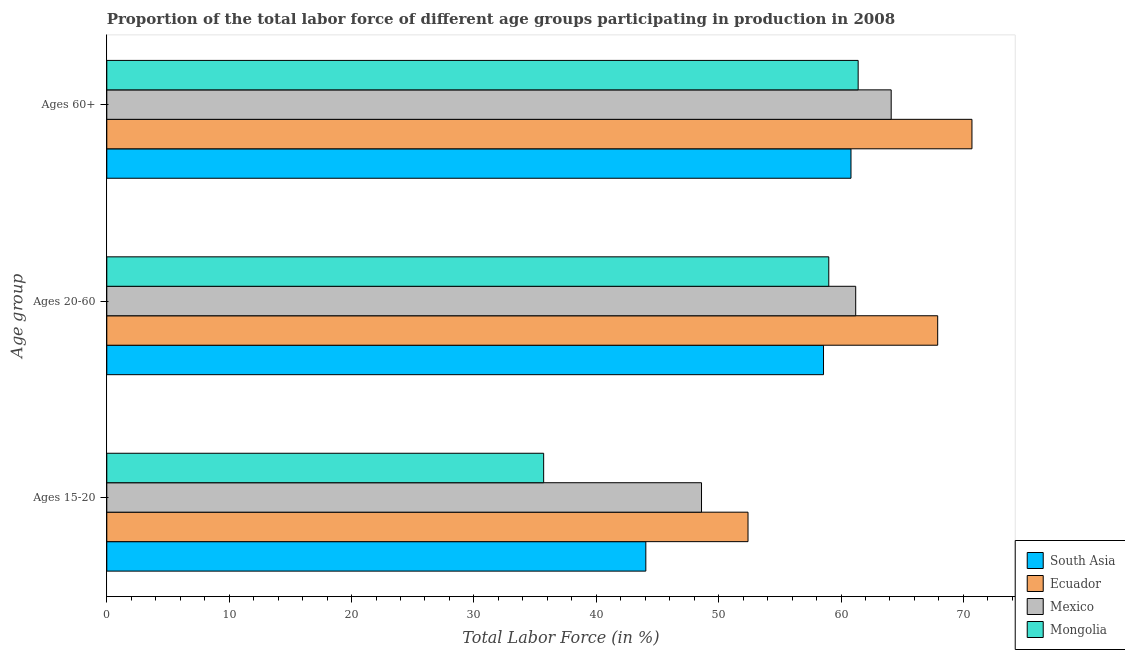How many different coloured bars are there?
Offer a terse response. 4. How many groups of bars are there?
Ensure brevity in your answer.  3. Are the number of bars per tick equal to the number of legend labels?
Ensure brevity in your answer.  Yes. Are the number of bars on each tick of the Y-axis equal?
Make the answer very short. Yes. How many bars are there on the 2nd tick from the top?
Make the answer very short. 4. What is the label of the 2nd group of bars from the top?
Provide a succinct answer. Ages 20-60. What is the percentage of labor force within the age group 20-60 in South Asia?
Your answer should be very brief. 58.57. Across all countries, what is the maximum percentage of labor force within the age group 20-60?
Your response must be concise. 67.9. Across all countries, what is the minimum percentage of labor force above age 60?
Your answer should be compact. 60.82. In which country was the percentage of labor force within the age group 15-20 maximum?
Keep it short and to the point. Ecuador. In which country was the percentage of labor force above age 60 minimum?
Ensure brevity in your answer.  South Asia. What is the total percentage of labor force within the age group 20-60 in the graph?
Your answer should be compact. 246.67. What is the difference between the percentage of labor force within the age group 15-20 in Mongolia and that in South Asia?
Make the answer very short. -8.35. What is the difference between the percentage of labor force above age 60 in Ecuador and the percentage of labor force within the age group 15-20 in Mongolia?
Give a very brief answer. 35. What is the average percentage of labor force within the age group 15-20 per country?
Provide a succinct answer. 45.19. What is the difference between the percentage of labor force above age 60 and percentage of labor force within the age group 20-60 in South Asia?
Offer a terse response. 2.25. In how many countries, is the percentage of labor force within the age group 20-60 greater than 60 %?
Your response must be concise. 2. What is the ratio of the percentage of labor force above age 60 in Mexico to that in Mongolia?
Offer a very short reply. 1.04. Is the difference between the percentage of labor force within the age group 20-60 in Mongolia and South Asia greater than the difference between the percentage of labor force above age 60 in Mongolia and South Asia?
Provide a succinct answer. No. What is the difference between the highest and the second highest percentage of labor force within the age group 15-20?
Your answer should be very brief. 3.8. What is the difference between the highest and the lowest percentage of labor force within the age group 15-20?
Your response must be concise. 16.7. In how many countries, is the percentage of labor force within the age group 20-60 greater than the average percentage of labor force within the age group 20-60 taken over all countries?
Keep it short and to the point. 1. Is the sum of the percentage of labor force within the age group 20-60 in Mongolia and Mexico greater than the maximum percentage of labor force above age 60 across all countries?
Provide a succinct answer. Yes. What does the 2nd bar from the top in Ages 15-20 represents?
Your answer should be very brief. Mexico. What does the 3rd bar from the bottom in Ages 60+ represents?
Provide a succinct answer. Mexico. Is it the case that in every country, the sum of the percentage of labor force within the age group 15-20 and percentage of labor force within the age group 20-60 is greater than the percentage of labor force above age 60?
Provide a short and direct response. Yes. How many bars are there?
Give a very brief answer. 12. Are all the bars in the graph horizontal?
Give a very brief answer. Yes. What is the difference between two consecutive major ticks on the X-axis?
Your answer should be compact. 10. Are the values on the major ticks of X-axis written in scientific E-notation?
Give a very brief answer. No. Where does the legend appear in the graph?
Make the answer very short. Bottom right. What is the title of the graph?
Provide a succinct answer. Proportion of the total labor force of different age groups participating in production in 2008. Does "India" appear as one of the legend labels in the graph?
Make the answer very short. No. What is the label or title of the X-axis?
Make the answer very short. Total Labor Force (in %). What is the label or title of the Y-axis?
Provide a short and direct response. Age group. What is the Total Labor Force (in %) of South Asia in Ages 15-20?
Ensure brevity in your answer.  44.05. What is the Total Labor Force (in %) of Ecuador in Ages 15-20?
Your answer should be compact. 52.4. What is the Total Labor Force (in %) of Mexico in Ages 15-20?
Make the answer very short. 48.6. What is the Total Labor Force (in %) of Mongolia in Ages 15-20?
Provide a short and direct response. 35.7. What is the Total Labor Force (in %) in South Asia in Ages 20-60?
Offer a terse response. 58.57. What is the Total Labor Force (in %) of Ecuador in Ages 20-60?
Ensure brevity in your answer.  67.9. What is the Total Labor Force (in %) in Mexico in Ages 20-60?
Offer a terse response. 61.2. What is the Total Labor Force (in %) of Mongolia in Ages 20-60?
Provide a short and direct response. 59. What is the Total Labor Force (in %) in South Asia in Ages 60+?
Offer a terse response. 60.82. What is the Total Labor Force (in %) of Ecuador in Ages 60+?
Offer a very short reply. 70.7. What is the Total Labor Force (in %) of Mexico in Ages 60+?
Your answer should be compact. 64.1. What is the Total Labor Force (in %) of Mongolia in Ages 60+?
Give a very brief answer. 61.4. Across all Age group, what is the maximum Total Labor Force (in %) in South Asia?
Offer a very short reply. 60.82. Across all Age group, what is the maximum Total Labor Force (in %) in Ecuador?
Give a very brief answer. 70.7. Across all Age group, what is the maximum Total Labor Force (in %) in Mexico?
Provide a succinct answer. 64.1. Across all Age group, what is the maximum Total Labor Force (in %) in Mongolia?
Provide a short and direct response. 61.4. Across all Age group, what is the minimum Total Labor Force (in %) in South Asia?
Offer a very short reply. 44.05. Across all Age group, what is the minimum Total Labor Force (in %) in Ecuador?
Provide a short and direct response. 52.4. Across all Age group, what is the minimum Total Labor Force (in %) in Mexico?
Provide a succinct answer. 48.6. Across all Age group, what is the minimum Total Labor Force (in %) in Mongolia?
Your answer should be very brief. 35.7. What is the total Total Labor Force (in %) in South Asia in the graph?
Offer a very short reply. 163.43. What is the total Total Labor Force (in %) of Ecuador in the graph?
Provide a short and direct response. 191. What is the total Total Labor Force (in %) of Mexico in the graph?
Offer a terse response. 173.9. What is the total Total Labor Force (in %) in Mongolia in the graph?
Your answer should be very brief. 156.1. What is the difference between the Total Labor Force (in %) of South Asia in Ages 15-20 and that in Ages 20-60?
Make the answer very short. -14.52. What is the difference between the Total Labor Force (in %) in Ecuador in Ages 15-20 and that in Ages 20-60?
Offer a very short reply. -15.5. What is the difference between the Total Labor Force (in %) of Mongolia in Ages 15-20 and that in Ages 20-60?
Ensure brevity in your answer.  -23.3. What is the difference between the Total Labor Force (in %) of South Asia in Ages 15-20 and that in Ages 60+?
Your response must be concise. -16.77. What is the difference between the Total Labor Force (in %) in Ecuador in Ages 15-20 and that in Ages 60+?
Your answer should be very brief. -18.3. What is the difference between the Total Labor Force (in %) of Mexico in Ages 15-20 and that in Ages 60+?
Ensure brevity in your answer.  -15.5. What is the difference between the Total Labor Force (in %) in Mongolia in Ages 15-20 and that in Ages 60+?
Your answer should be compact. -25.7. What is the difference between the Total Labor Force (in %) of South Asia in Ages 20-60 and that in Ages 60+?
Your answer should be very brief. -2.25. What is the difference between the Total Labor Force (in %) in South Asia in Ages 15-20 and the Total Labor Force (in %) in Ecuador in Ages 20-60?
Your answer should be compact. -23.85. What is the difference between the Total Labor Force (in %) of South Asia in Ages 15-20 and the Total Labor Force (in %) of Mexico in Ages 20-60?
Offer a terse response. -17.15. What is the difference between the Total Labor Force (in %) in South Asia in Ages 15-20 and the Total Labor Force (in %) in Mongolia in Ages 20-60?
Your answer should be compact. -14.95. What is the difference between the Total Labor Force (in %) of Mexico in Ages 15-20 and the Total Labor Force (in %) of Mongolia in Ages 20-60?
Your answer should be compact. -10.4. What is the difference between the Total Labor Force (in %) in South Asia in Ages 15-20 and the Total Labor Force (in %) in Ecuador in Ages 60+?
Make the answer very short. -26.65. What is the difference between the Total Labor Force (in %) of South Asia in Ages 15-20 and the Total Labor Force (in %) of Mexico in Ages 60+?
Keep it short and to the point. -20.05. What is the difference between the Total Labor Force (in %) of South Asia in Ages 15-20 and the Total Labor Force (in %) of Mongolia in Ages 60+?
Provide a succinct answer. -17.35. What is the difference between the Total Labor Force (in %) in Ecuador in Ages 15-20 and the Total Labor Force (in %) in Mexico in Ages 60+?
Offer a very short reply. -11.7. What is the difference between the Total Labor Force (in %) of Mexico in Ages 15-20 and the Total Labor Force (in %) of Mongolia in Ages 60+?
Provide a short and direct response. -12.8. What is the difference between the Total Labor Force (in %) in South Asia in Ages 20-60 and the Total Labor Force (in %) in Ecuador in Ages 60+?
Keep it short and to the point. -12.13. What is the difference between the Total Labor Force (in %) of South Asia in Ages 20-60 and the Total Labor Force (in %) of Mexico in Ages 60+?
Keep it short and to the point. -5.53. What is the difference between the Total Labor Force (in %) of South Asia in Ages 20-60 and the Total Labor Force (in %) of Mongolia in Ages 60+?
Offer a terse response. -2.83. What is the average Total Labor Force (in %) of South Asia per Age group?
Make the answer very short. 54.48. What is the average Total Labor Force (in %) in Ecuador per Age group?
Provide a short and direct response. 63.67. What is the average Total Labor Force (in %) of Mexico per Age group?
Provide a short and direct response. 57.97. What is the average Total Labor Force (in %) of Mongolia per Age group?
Offer a terse response. 52.03. What is the difference between the Total Labor Force (in %) of South Asia and Total Labor Force (in %) of Ecuador in Ages 15-20?
Provide a succinct answer. -8.35. What is the difference between the Total Labor Force (in %) in South Asia and Total Labor Force (in %) in Mexico in Ages 15-20?
Ensure brevity in your answer.  -4.55. What is the difference between the Total Labor Force (in %) of South Asia and Total Labor Force (in %) of Mongolia in Ages 15-20?
Provide a short and direct response. 8.35. What is the difference between the Total Labor Force (in %) of Ecuador and Total Labor Force (in %) of Mexico in Ages 15-20?
Ensure brevity in your answer.  3.8. What is the difference between the Total Labor Force (in %) of Ecuador and Total Labor Force (in %) of Mongolia in Ages 15-20?
Your answer should be compact. 16.7. What is the difference between the Total Labor Force (in %) in Mexico and Total Labor Force (in %) in Mongolia in Ages 15-20?
Your answer should be very brief. 12.9. What is the difference between the Total Labor Force (in %) of South Asia and Total Labor Force (in %) of Ecuador in Ages 20-60?
Your response must be concise. -9.33. What is the difference between the Total Labor Force (in %) of South Asia and Total Labor Force (in %) of Mexico in Ages 20-60?
Give a very brief answer. -2.63. What is the difference between the Total Labor Force (in %) of South Asia and Total Labor Force (in %) of Mongolia in Ages 20-60?
Offer a very short reply. -0.43. What is the difference between the Total Labor Force (in %) in Ecuador and Total Labor Force (in %) in Mongolia in Ages 20-60?
Offer a very short reply. 8.9. What is the difference between the Total Labor Force (in %) of South Asia and Total Labor Force (in %) of Ecuador in Ages 60+?
Give a very brief answer. -9.88. What is the difference between the Total Labor Force (in %) in South Asia and Total Labor Force (in %) in Mexico in Ages 60+?
Your response must be concise. -3.28. What is the difference between the Total Labor Force (in %) in South Asia and Total Labor Force (in %) in Mongolia in Ages 60+?
Give a very brief answer. -0.58. What is the difference between the Total Labor Force (in %) of Ecuador and Total Labor Force (in %) of Mongolia in Ages 60+?
Your response must be concise. 9.3. What is the difference between the Total Labor Force (in %) of Mexico and Total Labor Force (in %) of Mongolia in Ages 60+?
Provide a short and direct response. 2.7. What is the ratio of the Total Labor Force (in %) of South Asia in Ages 15-20 to that in Ages 20-60?
Provide a succinct answer. 0.75. What is the ratio of the Total Labor Force (in %) of Ecuador in Ages 15-20 to that in Ages 20-60?
Offer a terse response. 0.77. What is the ratio of the Total Labor Force (in %) of Mexico in Ages 15-20 to that in Ages 20-60?
Your answer should be very brief. 0.79. What is the ratio of the Total Labor Force (in %) in Mongolia in Ages 15-20 to that in Ages 20-60?
Offer a very short reply. 0.61. What is the ratio of the Total Labor Force (in %) of South Asia in Ages 15-20 to that in Ages 60+?
Keep it short and to the point. 0.72. What is the ratio of the Total Labor Force (in %) of Ecuador in Ages 15-20 to that in Ages 60+?
Your response must be concise. 0.74. What is the ratio of the Total Labor Force (in %) of Mexico in Ages 15-20 to that in Ages 60+?
Your answer should be compact. 0.76. What is the ratio of the Total Labor Force (in %) in Mongolia in Ages 15-20 to that in Ages 60+?
Your answer should be very brief. 0.58. What is the ratio of the Total Labor Force (in %) in South Asia in Ages 20-60 to that in Ages 60+?
Make the answer very short. 0.96. What is the ratio of the Total Labor Force (in %) in Ecuador in Ages 20-60 to that in Ages 60+?
Your answer should be compact. 0.96. What is the ratio of the Total Labor Force (in %) in Mexico in Ages 20-60 to that in Ages 60+?
Offer a terse response. 0.95. What is the ratio of the Total Labor Force (in %) of Mongolia in Ages 20-60 to that in Ages 60+?
Ensure brevity in your answer.  0.96. What is the difference between the highest and the second highest Total Labor Force (in %) of South Asia?
Ensure brevity in your answer.  2.25. What is the difference between the highest and the second highest Total Labor Force (in %) of Ecuador?
Provide a short and direct response. 2.8. What is the difference between the highest and the second highest Total Labor Force (in %) in Mexico?
Provide a short and direct response. 2.9. What is the difference between the highest and the second highest Total Labor Force (in %) in Mongolia?
Provide a short and direct response. 2.4. What is the difference between the highest and the lowest Total Labor Force (in %) of South Asia?
Your answer should be very brief. 16.77. What is the difference between the highest and the lowest Total Labor Force (in %) of Ecuador?
Provide a short and direct response. 18.3. What is the difference between the highest and the lowest Total Labor Force (in %) in Mongolia?
Your answer should be very brief. 25.7. 